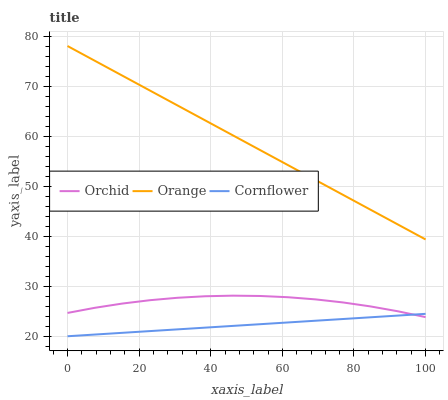Does Cornflower have the minimum area under the curve?
Answer yes or no. Yes. Does Orange have the maximum area under the curve?
Answer yes or no. Yes. Does Orchid have the minimum area under the curve?
Answer yes or no. No. Does Orchid have the maximum area under the curve?
Answer yes or no. No. Is Orange the smoothest?
Answer yes or no. Yes. Is Orchid the roughest?
Answer yes or no. Yes. Is Cornflower the smoothest?
Answer yes or no. No. Is Cornflower the roughest?
Answer yes or no. No. Does Cornflower have the lowest value?
Answer yes or no. Yes. Does Orchid have the lowest value?
Answer yes or no. No. Does Orange have the highest value?
Answer yes or no. Yes. Does Orchid have the highest value?
Answer yes or no. No. Is Orchid less than Orange?
Answer yes or no. Yes. Is Orange greater than Orchid?
Answer yes or no. Yes. Does Orchid intersect Cornflower?
Answer yes or no. Yes. Is Orchid less than Cornflower?
Answer yes or no. No. Is Orchid greater than Cornflower?
Answer yes or no. No. Does Orchid intersect Orange?
Answer yes or no. No. 